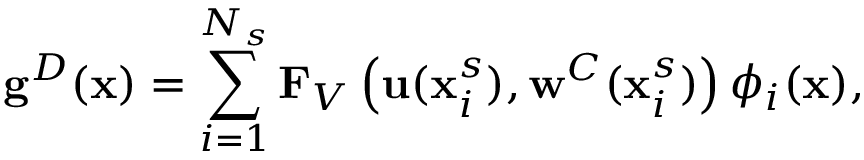Convert formula to latex. <formula><loc_0><loc_0><loc_500><loc_500>g ^ { D } ( x ) = \sum _ { i = 1 } ^ { N _ { s } } F _ { V } \left ( u ( x _ { i } ^ { s } ) , w ^ { C } ( x _ { i } ^ { s } ) \right ) { \phi } _ { i } ( x ) ,</formula> 